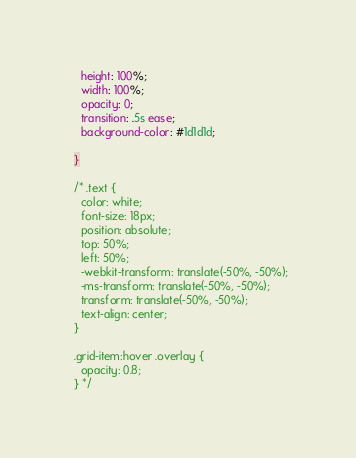Convert code to text. <code><loc_0><loc_0><loc_500><loc_500><_CSS_>    height: 100%;
    width: 100%;
    opacity: 0;
    transition: .5s ease;
    background-color: #1d1d1d;
    
  }
  
  /* .text {
    color: white;
    font-size: 18px;
    position: absolute;
    top: 50%;
    left: 50%;
    -webkit-transform: translate(-50%, -50%);
    -ms-transform: translate(-50%, -50%);
    transform: translate(-50%, -50%);
    text-align: center;
  }

  .grid-item:hover .overlay {
    opacity: 0.8;
  } */


</code> 